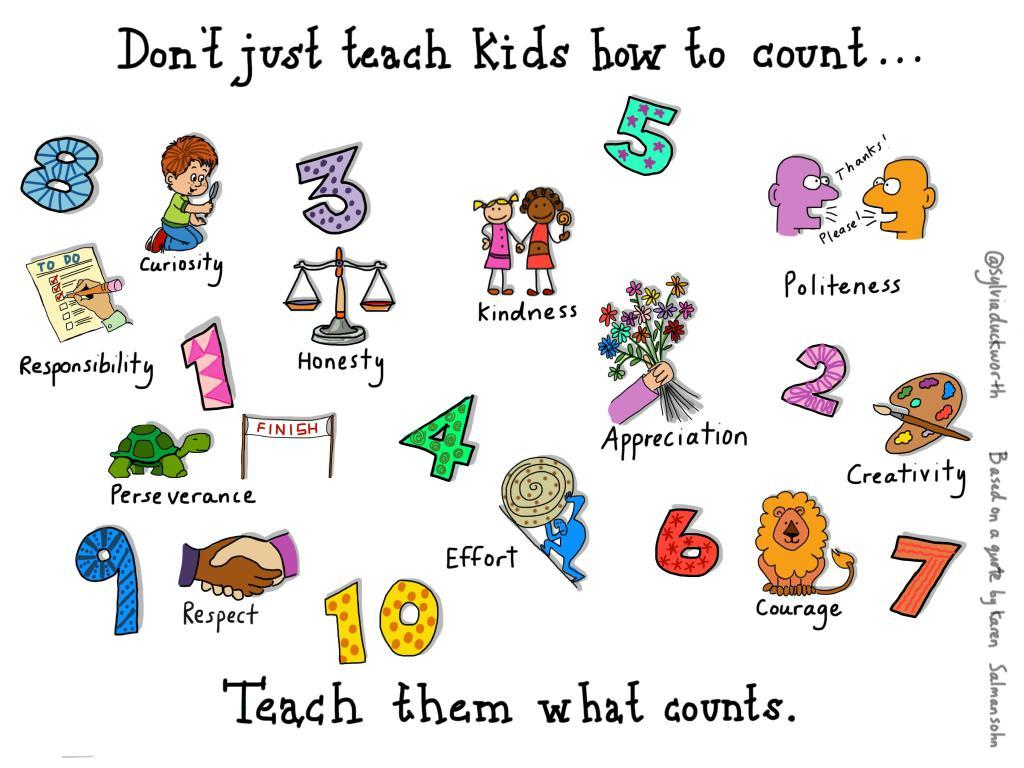What type of images are present in the image? There are cartoon pictures in the image. What else can be seen in the image besides the cartoon pictures? There are numbers in the image. What type of rake is used to maintain the existence of the numbers in the image? There is no rake present in the image, and the existence of the numbers does not require any maintenance. 